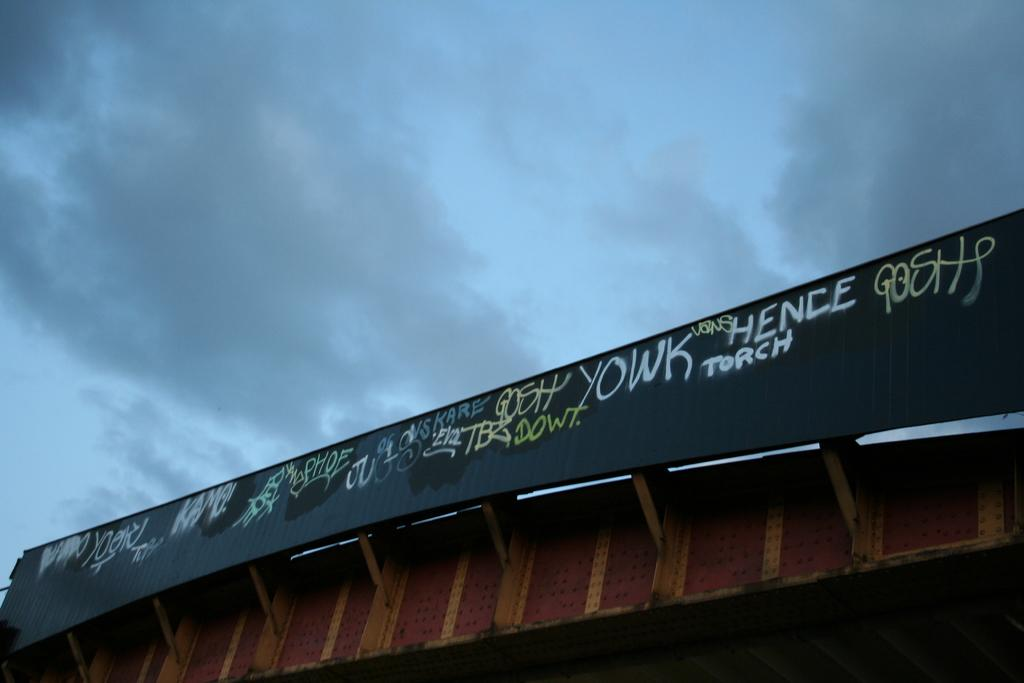Provide a one-sentence caption for the provided image. a bridge with graffiti on it saying Hence Torch. 